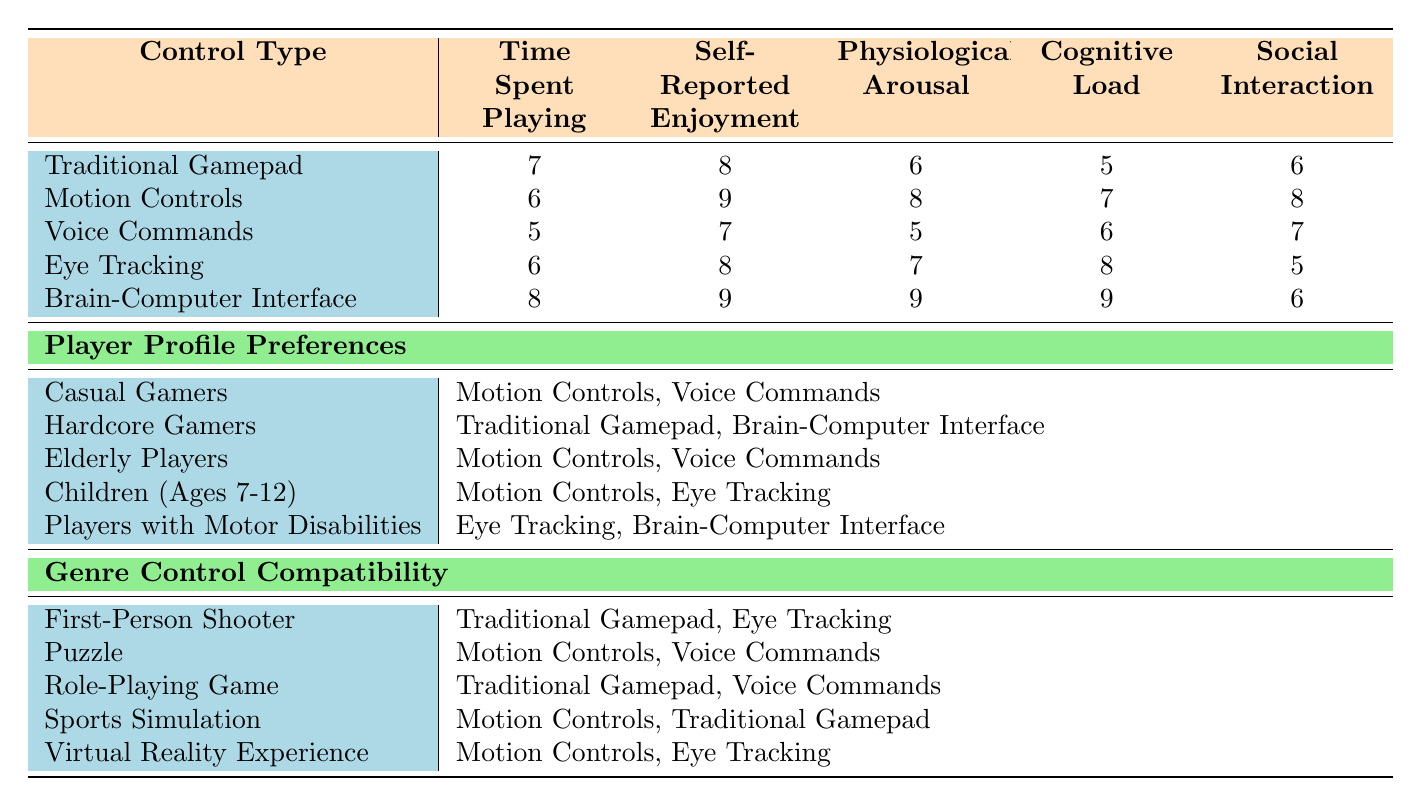What is the engagement score for "Self-Reported Enjoyment" using the Brain-Computer Interface? The table shows that the engagement score for "Self-Reported Enjoyment" under the "Brain-Computer Interface" control type is 9.
Answer: 9 Which control type has the highest score in "Physiological Arousal"? The table indicates that the "Brain-Computer Interface" has the highest score for "Physiological Arousal" at 9, higher than any other control type.
Answer: Brain-Computer Interface What is the average "Cognitive Load" score across all control types? To find the average, sum the scores for "Cognitive Load": (5 + 7 + 6 + 8 + 9) = 35. Then divide by the number of control types, which is 5: 35/5 = 7.
Answer: 7 Do Casual Gamers prefer Motion Controls over Voice Commands? The table indicates that Casual Gamers prefer both Motion Controls and Voice Commands, but specifically, Motion Controls is mentioned first, suggesting a preference.
Answer: Yes What is the difference in "Time Spent Playing" between Traditional Gamepad and Voice Commands? The score for Traditional Gamepad is 7 and for Voice Commands is 5. The difference is calculated as 7 - 5 = 2.
Answer: 2 Which player profile shows a preference for Eye Tracking and Brain-Computer Interface? By checking the player profile preferences, "Players with Motor Disabilities" is identified as the group that prefers both Eye Tracking and Brain-Computer Interface.
Answer: Players with Motor Disabilities How many control types have a score higher than 7 in "Self-Reported Enjoyment"? In the table, only the control types "Motion Controls" and "Brain-Computer Interface" have scores higher than 7 (9 and 9, respectively). Therefore, there are 2 control types.
Answer: 2 Is it true that all player profiles prefer at least one type of Motion Controls? The table shows that the preferences for Casual Gamers, Elderly Players, and Children all include Motion Controls, making it true that all these profiles prefer it. However, Hardcore Gamers only prefer Traditional Gamepad and Brain-Computer Interface. Thus, the statement is false.
Answer: No What control types are compatible with the Sports Simulation genre? The genres control compatibility section indicates that both Motion Controls and Traditional Gamepad are compatible with Sports Simulation.
Answer: Motion Controls, Traditional Gamepad 